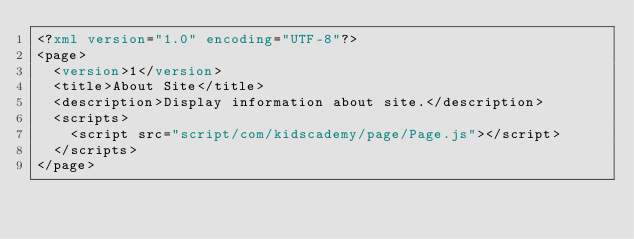Convert code to text. <code><loc_0><loc_0><loc_500><loc_500><_XML_><?xml version="1.0" encoding="UTF-8"?>
<page>
	<version>1</version>
	<title>About Site</title>
	<description>Display information about site.</description>
	<scripts>
		<script src="script/com/kidscademy/page/Page.js"></script>
	</scripts>
</page></code> 